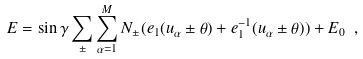<formula> <loc_0><loc_0><loc_500><loc_500>E = \sin \gamma \sum _ { \pm } \sum _ { \alpha = 1 } ^ { M } N _ { \pm } ( e _ { 1 } ( u _ { \alpha } \pm \theta ) + e _ { 1 } ^ { - 1 } ( u _ { \alpha } \pm \theta ) ) + E _ { 0 } \ ,</formula> 